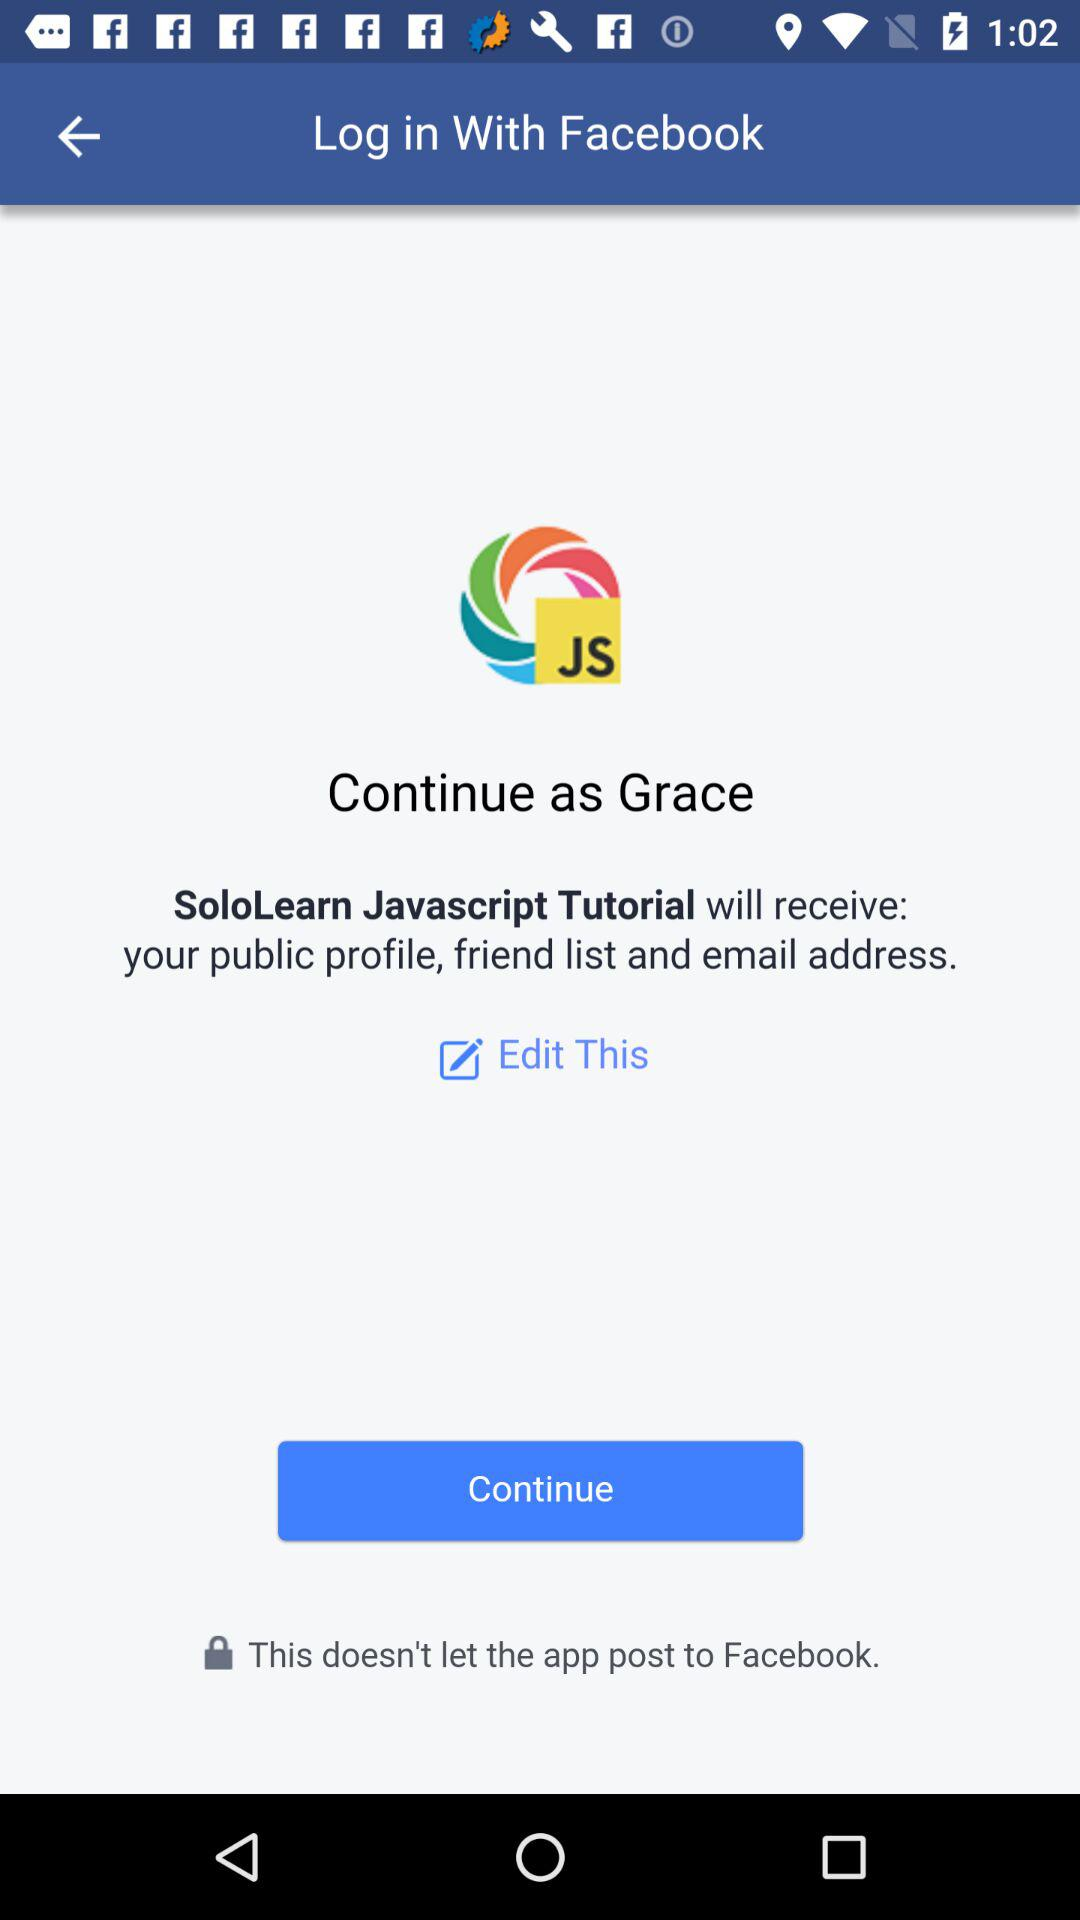What application is asking for permission? The application asking for permission is "SoloLearn Javascript Tutorial". 